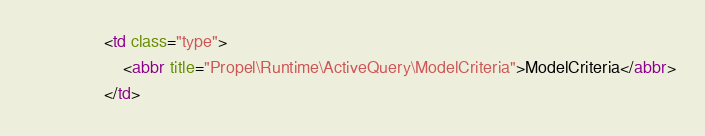Convert code to text. <code><loc_0><loc_0><loc_500><loc_500><_HTML_>                <td class="type">
                    <abbr title="Propel\Runtime\ActiveQuery\ModelCriteria">ModelCriteria</abbr>
                </td></code> 